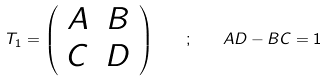<formula> <loc_0><loc_0><loc_500><loc_500>T _ { 1 } = \left ( \begin{array} { c c } A & B \\ C & D \end{array} \right ) \quad ; \quad A D - B C = 1</formula> 